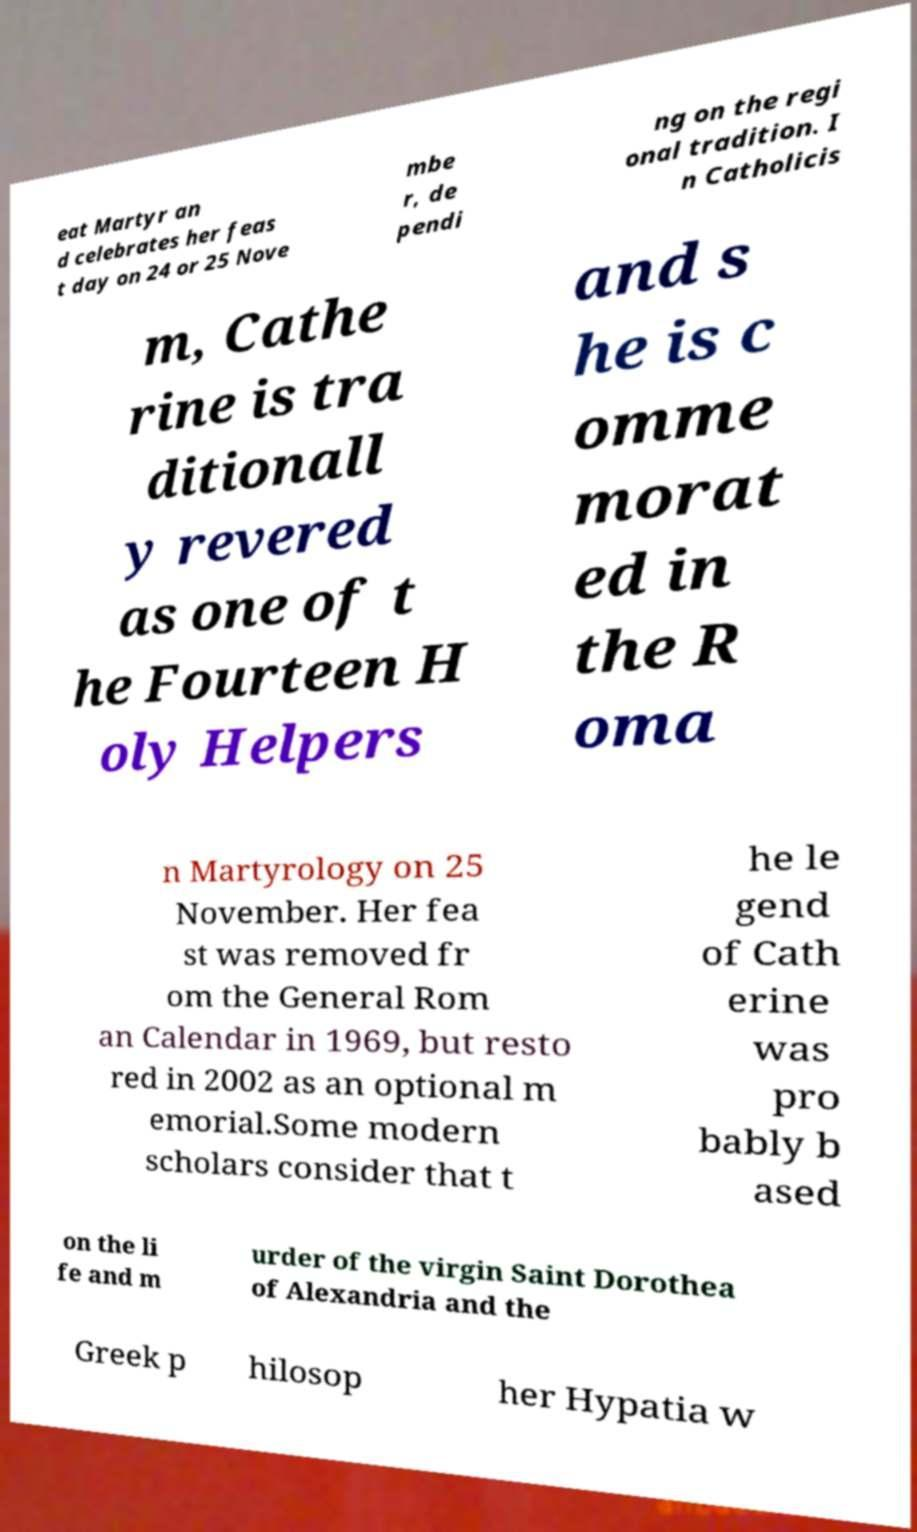I need the written content from this picture converted into text. Can you do that? eat Martyr an d celebrates her feas t day on 24 or 25 Nove mbe r, de pendi ng on the regi onal tradition. I n Catholicis m, Cathe rine is tra ditionall y revered as one of t he Fourteen H oly Helpers and s he is c omme morat ed in the R oma n Martyrology on 25 November. Her fea st was removed fr om the General Rom an Calendar in 1969, but resto red in 2002 as an optional m emorial.Some modern scholars consider that t he le gend of Cath erine was pro bably b ased on the li fe and m urder of the virgin Saint Dorothea of Alexandria and the Greek p hilosop her Hypatia w 